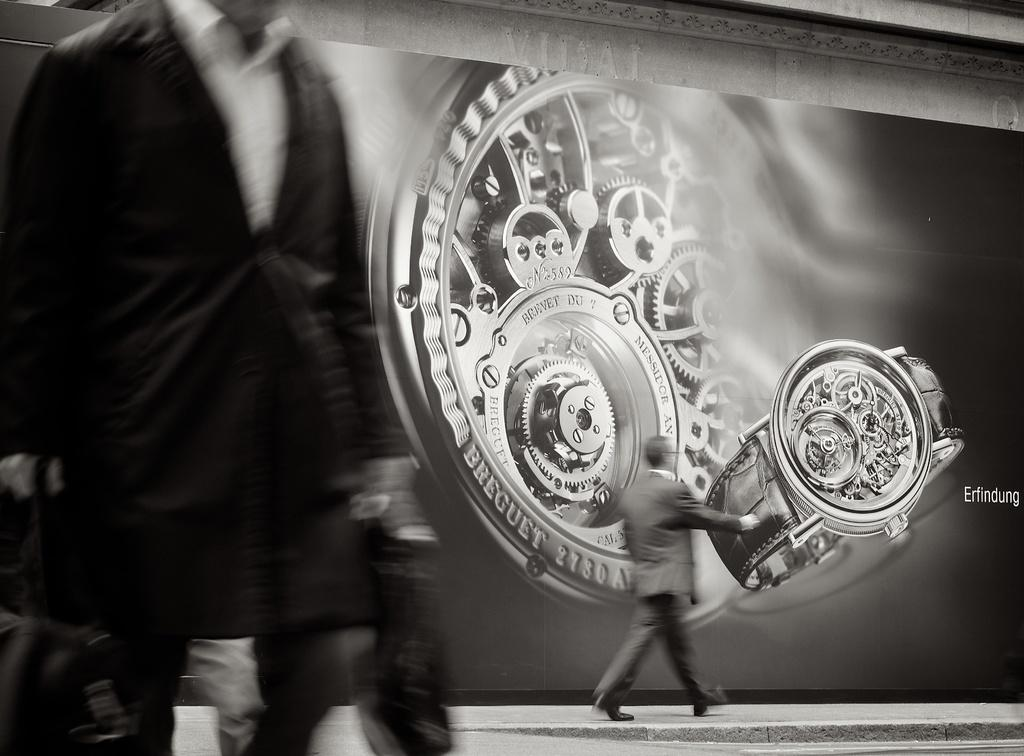<image>
Relay a brief, clear account of the picture shown. An ad for Breguet watches features the inner workings of a watch. 